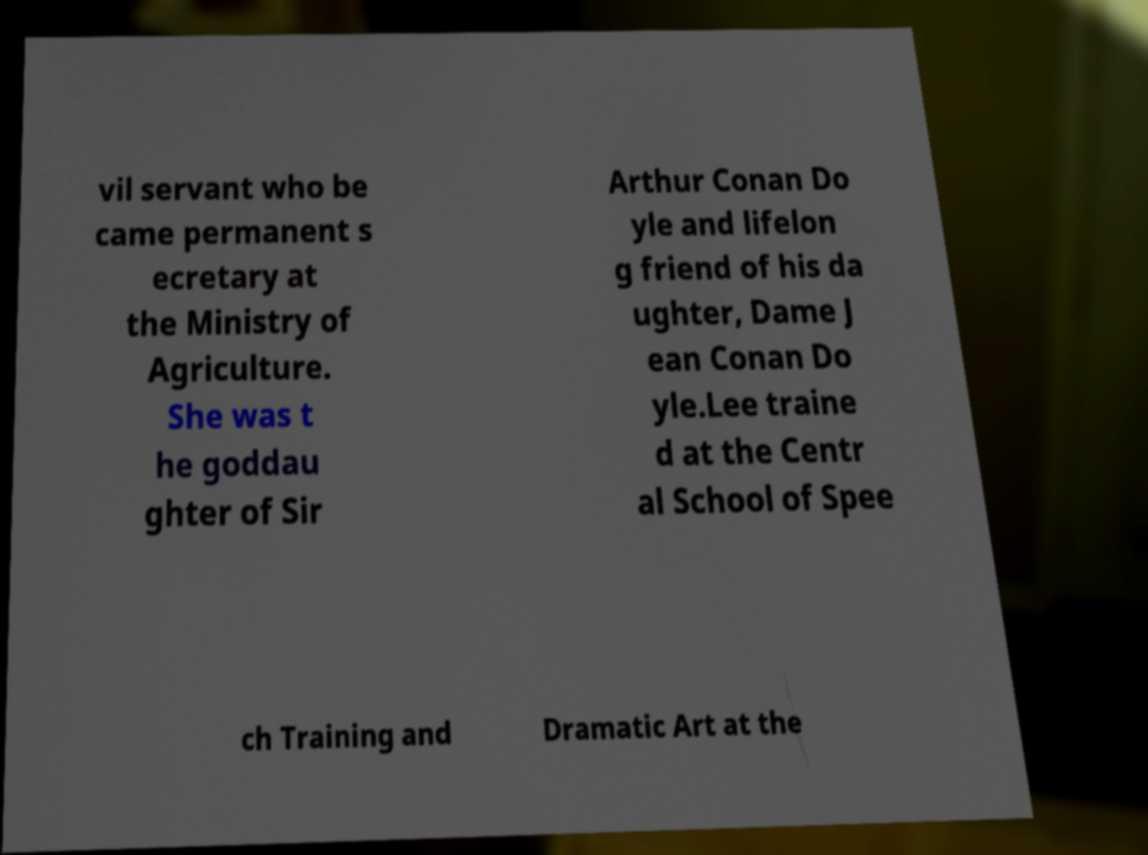I need the written content from this picture converted into text. Can you do that? vil servant who be came permanent s ecretary at the Ministry of Agriculture. She was t he goddau ghter of Sir Arthur Conan Do yle and lifelon g friend of his da ughter, Dame J ean Conan Do yle.Lee traine d at the Centr al School of Spee ch Training and Dramatic Art at the 